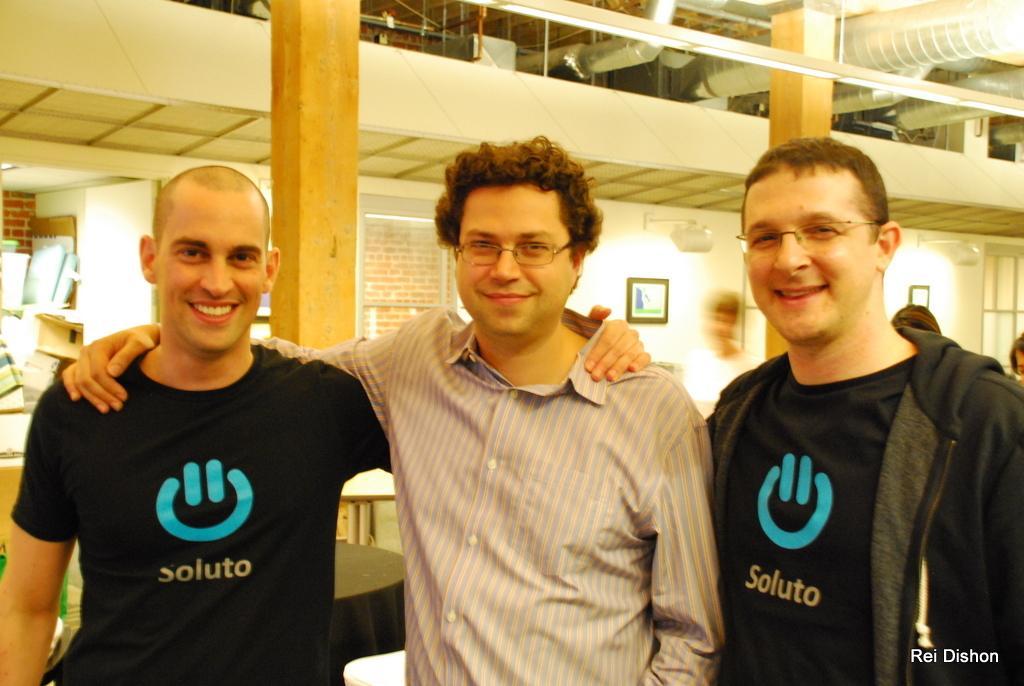How would you summarize this image in a sentence or two? In the picture we can see three men are standing together, holding each other and smiling and two men are wearing black T-shirts and one man is wearing a shirt and in the background, we can see some pillars and wall, on the wall we can see photo frames and some lights on the wall. 